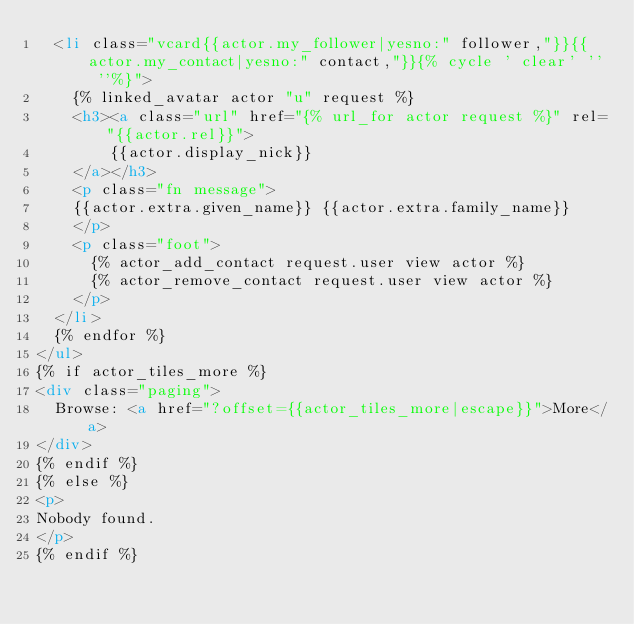Convert code to text. <code><loc_0><loc_0><loc_500><loc_500><_HTML_>  <li class="vcard{{actor.my_follower|yesno:" follower,"}}{{actor.my_contact|yesno:" contact,"}}{% cycle ' clear' '' ''%}">
    {% linked_avatar actor "u" request %}
    <h3><a class="url" href="{% url_for actor request %}" rel="{{actor.rel}}">
        {{actor.display_nick}}
    </a></h3>
    <p class="fn message">
    {{actor.extra.given_name}} {{actor.extra.family_name}}
    </p>
    <p class="foot">
      {% actor_add_contact request.user view actor %}
      {% actor_remove_contact request.user view actor %}
    </p>
  </li>
  {% endfor %}
</ul>
{% if actor_tiles_more %}
<div class="paging">
  Browse: <a href="?offset={{actor_tiles_more|escape}}">More</a>
</div>
{% endif %}
{% else %}
<p>
Nobody found.
</p>
{% endif %}

</code> 